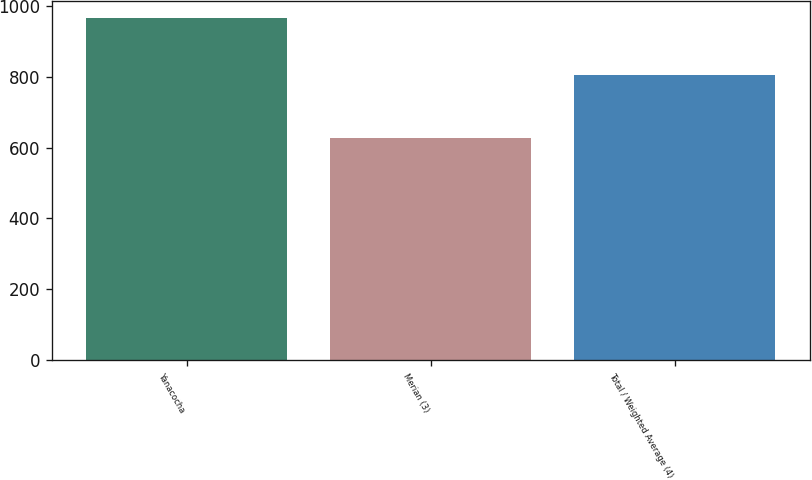<chart> <loc_0><loc_0><loc_500><loc_500><bar_chart><fcel>Yanacocha<fcel>Merian (3)<fcel>Total / Weighted Average (4)<nl><fcel>967<fcel>627<fcel>804<nl></chart> 